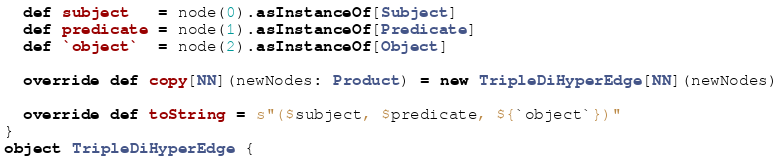<code> <loc_0><loc_0><loc_500><loc_500><_Scala_>  def subject   = node(0).asInstanceOf[Subject]
  def predicate = node(1).asInstanceOf[Predicate]
  def `object`  = node(2).asInstanceOf[Object]

  override def copy[NN](newNodes: Product) = new TripleDiHyperEdge[NN](newNodes)

  override def toString = s"($subject, $predicate, ${`object`})"
}
object TripleDiHyperEdge {</code> 